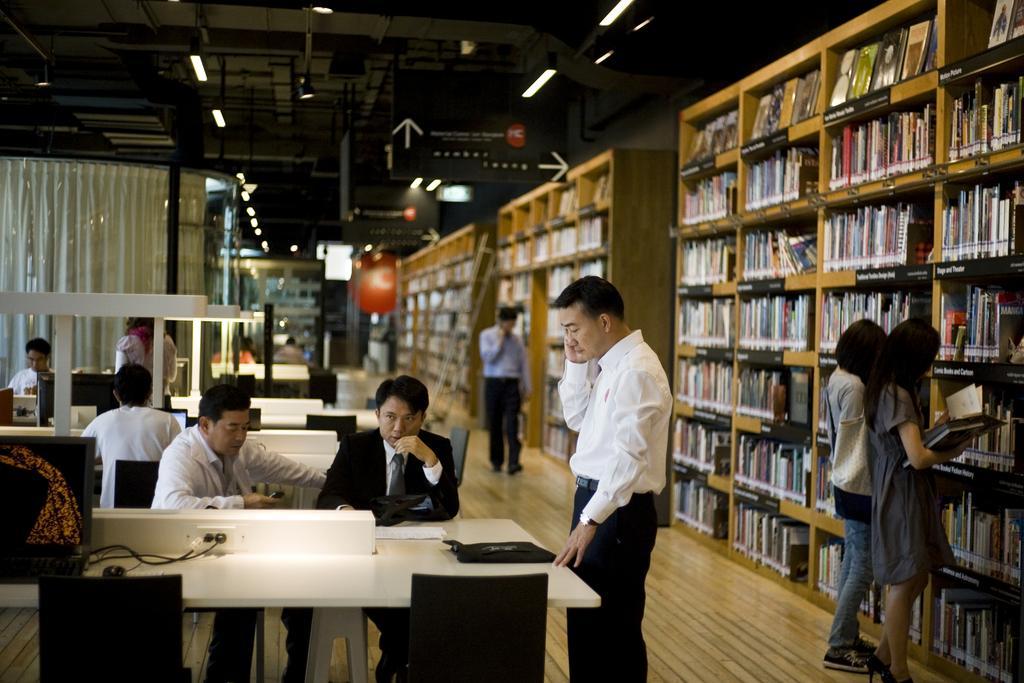How would you summarize this image in a sentence or two? in a room there are white tables around which there are black chairs. 2 people are sitting on the chairs. the person at the right is wearing black suit and the person at the left is wearing white shirt. at the right a person is standing wearing white shirt and black pant. behind them there are other people sitting. at the right there are many bookshelves. 2 people are standing at the left and reading books. at the back a person is walking. there is a ladder at the back. at the right back there are curtains. on the top right there are hoardings with arrow marks on it. on the top there are lights. 